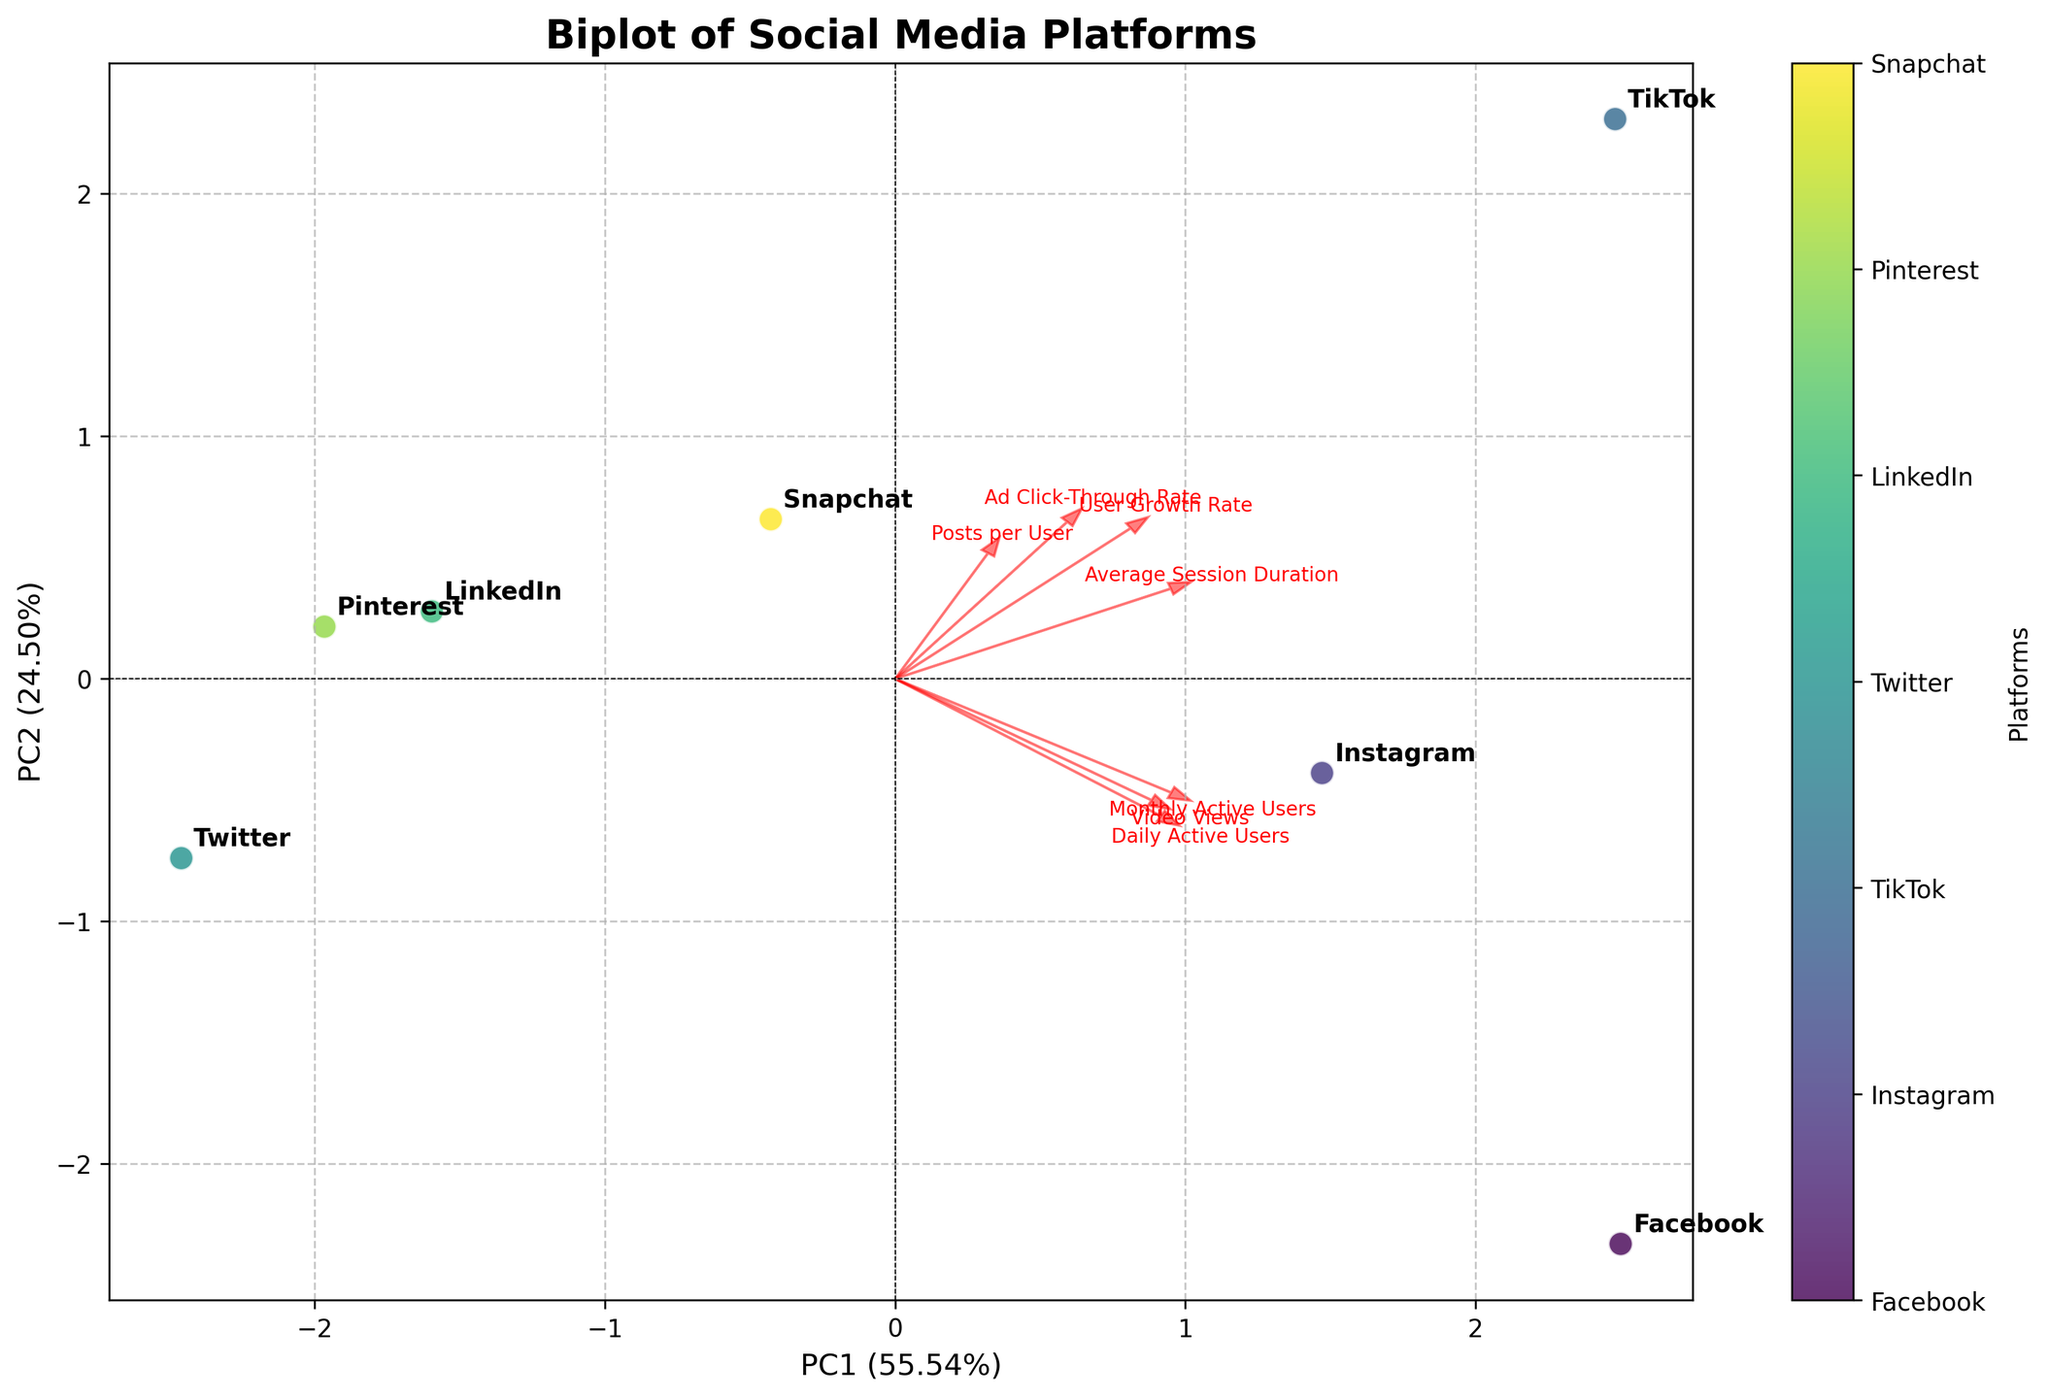Which platform has the highest score on PC1? To determine which platform has the highest score on PC1, look at the points along the PC1 axis (the x-axis on the plot). Identify the point that lies furthest to the right.
Answer: TikTok What are the two main components in the biplot? The two main components in the biplot are PC1 and PC2, which represent the principal components derived from the PCA analysis. These axes are labeled on the plot.
Answer: PC1 and PC2 Which feature has the highest loading on PC2? The feature with the highest loading on PC2 can be identified by looking at the arrows pointing towards or away from the PC2 axis (y-axis). The feature with the arrow most closely aligned with the PC2 axis has the highest loading.
Answer: Average Session Duration How does Facebook compare to Twitter in terms of their PC1 score? Look at the positions of the Facebook and Twitter points on the PC1 axis (x-axis). Facebook's point is much further to the right compared to Twitter's, indicating a higher PC1 score.
Answer: Facebook has a higher PC1 score Which features are more associated with higher PC1 values? To determine which features are more associated with higher PC1 values, look at the direction of the arrows relative to the PC1 axis (x-axis). Features with arrows pointing towards the right indicate an association with higher PC1 values.
Answer: Daily Active Users, Monthly Active Users, Video Views Which platform appears closest to the origin? Find the point on the plot that is nearest to the origin (0,0). This point is closest to both the PC1 and PC2 axes and can be identified visually.
Answer: LinkedIn How does TikTok's user growth rate appear in the context of the PCA components? To understand TikTok's user growth rate in the context of the PCA components, examine the position of TikTok relative to the User Growth Rate arrow. TikTok's point is closely aligned with the arrow for User Growth Rate, indicating high user growth.
Answer: High alignment with User Growth Rate What is the percentage of variance explained by PC1 and PC2 together? Look at the x and y labels of the plot, which provide the percentage of variance explained by each principal component. Add these percentages together to get the total variance explained by both components.
Answer: [Percentage from PC1] + [Percentage from PC2] Which platform has the lowest Ad Click-Through Rate, inferred by PC2? To infer which platform has the lowest Ad Click-Through Rate by PC2, identify the feature (Ad Click-Through Rate) and observe which platform's point is in the opposite direction of the arrow for PC2.
Answer: Twitter 